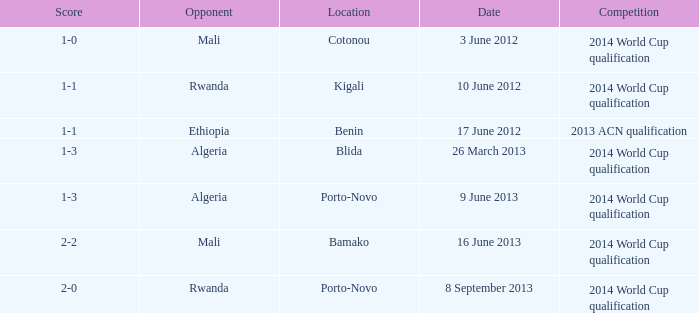What competition is located in bamako? 2014 World Cup qualification. 